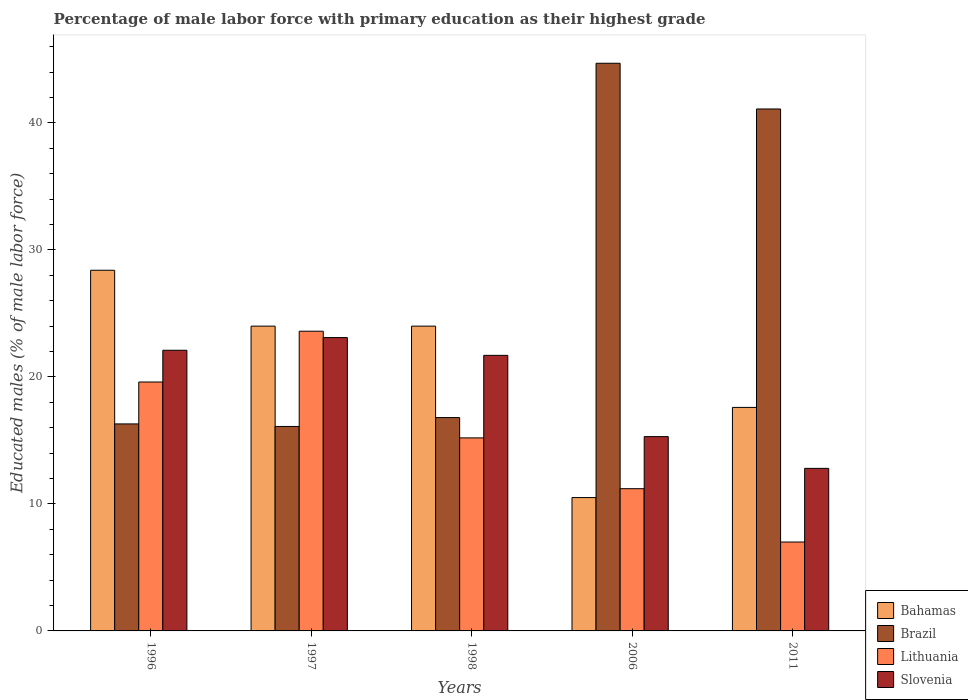How many groups of bars are there?
Make the answer very short. 5. Are the number of bars on each tick of the X-axis equal?
Offer a very short reply. Yes. How many bars are there on the 5th tick from the left?
Provide a succinct answer. 4. Across all years, what is the maximum percentage of male labor force with primary education in Slovenia?
Make the answer very short. 23.1. In which year was the percentage of male labor force with primary education in Slovenia minimum?
Your answer should be very brief. 2011. What is the total percentage of male labor force with primary education in Slovenia in the graph?
Your answer should be compact. 95. What is the difference between the percentage of male labor force with primary education in Bahamas in 1996 and that in 1997?
Your answer should be compact. 4.4. What is the difference between the percentage of male labor force with primary education in Brazil in 2011 and the percentage of male labor force with primary education in Bahamas in 1996?
Offer a terse response. 12.7. What is the average percentage of male labor force with primary education in Lithuania per year?
Provide a short and direct response. 15.32. In the year 2011, what is the difference between the percentage of male labor force with primary education in Bahamas and percentage of male labor force with primary education in Slovenia?
Make the answer very short. 4.8. What is the ratio of the percentage of male labor force with primary education in Brazil in 1996 to that in 1998?
Ensure brevity in your answer.  0.97. Is the difference between the percentage of male labor force with primary education in Bahamas in 1996 and 1998 greater than the difference between the percentage of male labor force with primary education in Slovenia in 1996 and 1998?
Keep it short and to the point. Yes. What is the difference between the highest and the second highest percentage of male labor force with primary education in Brazil?
Offer a terse response. 3.6. What is the difference between the highest and the lowest percentage of male labor force with primary education in Slovenia?
Keep it short and to the point. 10.3. Is the sum of the percentage of male labor force with primary education in Slovenia in 1998 and 2011 greater than the maximum percentage of male labor force with primary education in Lithuania across all years?
Keep it short and to the point. Yes. What does the 1st bar from the left in 1997 represents?
Provide a short and direct response. Bahamas. What does the 1st bar from the right in 1997 represents?
Provide a short and direct response. Slovenia. Is it the case that in every year, the sum of the percentage of male labor force with primary education in Bahamas and percentage of male labor force with primary education in Brazil is greater than the percentage of male labor force with primary education in Slovenia?
Your answer should be compact. Yes. What is the difference between two consecutive major ticks on the Y-axis?
Keep it short and to the point. 10. Are the values on the major ticks of Y-axis written in scientific E-notation?
Provide a short and direct response. No. Where does the legend appear in the graph?
Give a very brief answer. Bottom right. How are the legend labels stacked?
Provide a short and direct response. Vertical. What is the title of the graph?
Provide a short and direct response. Percentage of male labor force with primary education as their highest grade. What is the label or title of the Y-axis?
Offer a very short reply. Educated males (% of male labor force). What is the Educated males (% of male labor force) of Bahamas in 1996?
Ensure brevity in your answer.  28.4. What is the Educated males (% of male labor force) of Brazil in 1996?
Make the answer very short. 16.3. What is the Educated males (% of male labor force) in Lithuania in 1996?
Your answer should be very brief. 19.6. What is the Educated males (% of male labor force) of Slovenia in 1996?
Keep it short and to the point. 22.1. What is the Educated males (% of male labor force) in Brazil in 1997?
Offer a very short reply. 16.1. What is the Educated males (% of male labor force) in Lithuania in 1997?
Give a very brief answer. 23.6. What is the Educated males (% of male labor force) of Slovenia in 1997?
Offer a terse response. 23.1. What is the Educated males (% of male labor force) in Brazil in 1998?
Offer a very short reply. 16.8. What is the Educated males (% of male labor force) of Lithuania in 1998?
Ensure brevity in your answer.  15.2. What is the Educated males (% of male labor force) of Slovenia in 1998?
Keep it short and to the point. 21.7. What is the Educated males (% of male labor force) in Brazil in 2006?
Provide a short and direct response. 44.7. What is the Educated males (% of male labor force) of Lithuania in 2006?
Your answer should be compact. 11.2. What is the Educated males (% of male labor force) of Slovenia in 2006?
Your response must be concise. 15.3. What is the Educated males (% of male labor force) of Bahamas in 2011?
Your response must be concise. 17.6. What is the Educated males (% of male labor force) of Brazil in 2011?
Provide a succinct answer. 41.1. What is the Educated males (% of male labor force) of Lithuania in 2011?
Provide a short and direct response. 7. What is the Educated males (% of male labor force) of Slovenia in 2011?
Ensure brevity in your answer.  12.8. Across all years, what is the maximum Educated males (% of male labor force) in Bahamas?
Your answer should be compact. 28.4. Across all years, what is the maximum Educated males (% of male labor force) in Brazil?
Offer a terse response. 44.7. Across all years, what is the maximum Educated males (% of male labor force) of Lithuania?
Make the answer very short. 23.6. Across all years, what is the maximum Educated males (% of male labor force) in Slovenia?
Give a very brief answer. 23.1. Across all years, what is the minimum Educated males (% of male labor force) of Bahamas?
Offer a terse response. 10.5. Across all years, what is the minimum Educated males (% of male labor force) in Brazil?
Your answer should be very brief. 16.1. Across all years, what is the minimum Educated males (% of male labor force) in Lithuania?
Your answer should be very brief. 7. Across all years, what is the minimum Educated males (% of male labor force) of Slovenia?
Make the answer very short. 12.8. What is the total Educated males (% of male labor force) in Bahamas in the graph?
Give a very brief answer. 104.5. What is the total Educated males (% of male labor force) of Brazil in the graph?
Your answer should be very brief. 135. What is the total Educated males (% of male labor force) in Lithuania in the graph?
Give a very brief answer. 76.6. What is the difference between the Educated males (% of male labor force) in Brazil in 1996 and that in 1997?
Offer a terse response. 0.2. What is the difference between the Educated males (% of male labor force) in Lithuania in 1996 and that in 1997?
Your answer should be compact. -4. What is the difference between the Educated males (% of male labor force) of Brazil in 1996 and that in 1998?
Your answer should be compact. -0.5. What is the difference between the Educated males (% of male labor force) in Lithuania in 1996 and that in 1998?
Your answer should be compact. 4.4. What is the difference between the Educated males (% of male labor force) in Brazil in 1996 and that in 2006?
Your response must be concise. -28.4. What is the difference between the Educated males (% of male labor force) of Lithuania in 1996 and that in 2006?
Make the answer very short. 8.4. What is the difference between the Educated males (% of male labor force) of Brazil in 1996 and that in 2011?
Your response must be concise. -24.8. What is the difference between the Educated males (% of male labor force) in Lithuania in 1996 and that in 2011?
Give a very brief answer. 12.6. What is the difference between the Educated males (% of male labor force) in Slovenia in 1996 and that in 2011?
Keep it short and to the point. 9.3. What is the difference between the Educated males (% of male labor force) of Lithuania in 1997 and that in 1998?
Provide a succinct answer. 8.4. What is the difference between the Educated males (% of male labor force) in Slovenia in 1997 and that in 1998?
Offer a very short reply. 1.4. What is the difference between the Educated males (% of male labor force) in Brazil in 1997 and that in 2006?
Offer a very short reply. -28.6. What is the difference between the Educated males (% of male labor force) of Lithuania in 1997 and that in 2006?
Ensure brevity in your answer.  12.4. What is the difference between the Educated males (% of male labor force) of Slovenia in 1997 and that in 2011?
Ensure brevity in your answer.  10.3. What is the difference between the Educated males (% of male labor force) of Bahamas in 1998 and that in 2006?
Your response must be concise. 13.5. What is the difference between the Educated males (% of male labor force) in Brazil in 1998 and that in 2006?
Keep it short and to the point. -27.9. What is the difference between the Educated males (% of male labor force) in Slovenia in 1998 and that in 2006?
Your response must be concise. 6.4. What is the difference between the Educated males (% of male labor force) of Brazil in 1998 and that in 2011?
Offer a terse response. -24.3. What is the difference between the Educated males (% of male labor force) of Bahamas in 2006 and that in 2011?
Your answer should be compact. -7.1. What is the difference between the Educated males (% of male labor force) of Slovenia in 2006 and that in 2011?
Provide a succinct answer. 2.5. What is the difference between the Educated males (% of male labor force) in Bahamas in 1996 and the Educated males (% of male labor force) in Brazil in 1997?
Provide a short and direct response. 12.3. What is the difference between the Educated males (% of male labor force) in Bahamas in 1996 and the Educated males (% of male labor force) in Lithuania in 1997?
Offer a very short reply. 4.8. What is the difference between the Educated males (% of male labor force) in Bahamas in 1996 and the Educated males (% of male labor force) in Slovenia in 1997?
Keep it short and to the point. 5.3. What is the difference between the Educated males (% of male labor force) in Lithuania in 1996 and the Educated males (% of male labor force) in Slovenia in 1998?
Keep it short and to the point. -2.1. What is the difference between the Educated males (% of male labor force) of Bahamas in 1996 and the Educated males (% of male labor force) of Brazil in 2006?
Make the answer very short. -16.3. What is the difference between the Educated males (% of male labor force) of Bahamas in 1996 and the Educated males (% of male labor force) of Lithuania in 2006?
Your response must be concise. 17.2. What is the difference between the Educated males (% of male labor force) of Bahamas in 1996 and the Educated males (% of male labor force) of Slovenia in 2006?
Ensure brevity in your answer.  13.1. What is the difference between the Educated males (% of male labor force) in Brazil in 1996 and the Educated males (% of male labor force) in Slovenia in 2006?
Provide a short and direct response. 1. What is the difference between the Educated males (% of male labor force) of Bahamas in 1996 and the Educated males (% of male labor force) of Brazil in 2011?
Keep it short and to the point. -12.7. What is the difference between the Educated males (% of male labor force) of Bahamas in 1996 and the Educated males (% of male labor force) of Lithuania in 2011?
Provide a short and direct response. 21.4. What is the difference between the Educated males (% of male labor force) in Bahamas in 1996 and the Educated males (% of male labor force) in Slovenia in 2011?
Make the answer very short. 15.6. What is the difference between the Educated males (% of male labor force) in Brazil in 1996 and the Educated males (% of male labor force) in Lithuania in 2011?
Give a very brief answer. 9.3. What is the difference between the Educated males (% of male labor force) in Brazil in 1996 and the Educated males (% of male labor force) in Slovenia in 2011?
Make the answer very short. 3.5. What is the difference between the Educated males (% of male labor force) in Lithuania in 1996 and the Educated males (% of male labor force) in Slovenia in 2011?
Offer a terse response. 6.8. What is the difference between the Educated males (% of male labor force) of Bahamas in 1997 and the Educated males (% of male labor force) of Brazil in 1998?
Make the answer very short. 7.2. What is the difference between the Educated males (% of male labor force) of Bahamas in 1997 and the Educated males (% of male labor force) of Lithuania in 1998?
Keep it short and to the point. 8.8. What is the difference between the Educated males (% of male labor force) in Brazil in 1997 and the Educated males (% of male labor force) in Lithuania in 1998?
Your answer should be very brief. 0.9. What is the difference between the Educated males (% of male labor force) of Bahamas in 1997 and the Educated males (% of male labor force) of Brazil in 2006?
Your answer should be very brief. -20.7. What is the difference between the Educated males (% of male labor force) of Bahamas in 1997 and the Educated males (% of male labor force) of Lithuania in 2006?
Provide a short and direct response. 12.8. What is the difference between the Educated males (% of male labor force) of Bahamas in 1997 and the Educated males (% of male labor force) of Slovenia in 2006?
Keep it short and to the point. 8.7. What is the difference between the Educated males (% of male labor force) of Lithuania in 1997 and the Educated males (% of male labor force) of Slovenia in 2006?
Keep it short and to the point. 8.3. What is the difference between the Educated males (% of male labor force) in Bahamas in 1997 and the Educated males (% of male labor force) in Brazil in 2011?
Offer a terse response. -17.1. What is the difference between the Educated males (% of male labor force) of Brazil in 1997 and the Educated males (% of male labor force) of Lithuania in 2011?
Ensure brevity in your answer.  9.1. What is the difference between the Educated males (% of male labor force) in Brazil in 1997 and the Educated males (% of male labor force) in Slovenia in 2011?
Keep it short and to the point. 3.3. What is the difference between the Educated males (% of male labor force) in Lithuania in 1997 and the Educated males (% of male labor force) in Slovenia in 2011?
Your answer should be very brief. 10.8. What is the difference between the Educated males (% of male labor force) in Bahamas in 1998 and the Educated males (% of male labor force) in Brazil in 2006?
Keep it short and to the point. -20.7. What is the difference between the Educated males (% of male labor force) in Bahamas in 1998 and the Educated males (% of male labor force) in Slovenia in 2006?
Offer a very short reply. 8.7. What is the difference between the Educated males (% of male labor force) in Lithuania in 1998 and the Educated males (% of male labor force) in Slovenia in 2006?
Provide a short and direct response. -0.1. What is the difference between the Educated males (% of male labor force) in Bahamas in 1998 and the Educated males (% of male labor force) in Brazil in 2011?
Your answer should be very brief. -17.1. What is the difference between the Educated males (% of male labor force) in Bahamas in 1998 and the Educated males (% of male labor force) in Lithuania in 2011?
Make the answer very short. 17. What is the difference between the Educated males (% of male labor force) in Brazil in 1998 and the Educated males (% of male labor force) in Lithuania in 2011?
Ensure brevity in your answer.  9.8. What is the difference between the Educated males (% of male labor force) in Brazil in 1998 and the Educated males (% of male labor force) in Slovenia in 2011?
Ensure brevity in your answer.  4. What is the difference between the Educated males (% of male labor force) in Bahamas in 2006 and the Educated males (% of male labor force) in Brazil in 2011?
Give a very brief answer. -30.6. What is the difference between the Educated males (% of male labor force) of Bahamas in 2006 and the Educated males (% of male labor force) of Lithuania in 2011?
Offer a very short reply. 3.5. What is the difference between the Educated males (% of male labor force) of Bahamas in 2006 and the Educated males (% of male labor force) of Slovenia in 2011?
Give a very brief answer. -2.3. What is the difference between the Educated males (% of male labor force) in Brazil in 2006 and the Educated males (% of male labor force) in Lithuania in 2011?
Offer a very short reply. 37.7. What is the difference between the Educated males (% of male labor force) of Brazil in 2006 and the Educated males (% of male labor force) of Slovenia in 2011?
Provide a succinct answer. 31.9. What is the average Educated males (% of male labor force) of Bahamas per year?
Your answer should be very brief. 20.9. What is the average Educated males (% of male labor force) of Lithuania per year?
Your answer should be very brief. 15.32. What is the average Educated males (% of male labor force) in Slovenia per year?
Keep it short and to the point. 19. In the year 1996, what is the difference between the Educated males (% of male labor force) of Bahamas and Educated males (% of male labor force) of Brazil?
Keep it short and to the point. 12.1. In the year 1996, what is the difference between the Educated males (% of male labor force) in Brazil and Educated males (% of male labor force) in Slovenia?
Your answer should be very brief. -5.8. In the year 1996, what is the difference between the Educated males (% of male labor force) of Lithuania and Educated males (% of male labor force) of Slovenia?
Your response must be concise. -2.5. In the year 1997, what is the difference between the Educated males (% of male labor force) of Brazil and Educated males (% of male labor force) of Slovenia?
Make the answer very short. -7. In the year 1998, what is the difference between the Educated males (% of male labor force) of Bahamas and Educated males (% of male labor force) of Lithuania?
Provide a short and direct response. 8.8. In the year 1998, what is the difference between the Educated males (% of male labor force) in Bahamas and Educated males (% of male labor force) in Slovenia?
Provide a succinct answer. 2.3. In the year 1998, what is the difference between the Educated males (% of male labor force) in Brazil and Educated males (% of male labor force) in Lithuania?
Give a very brief answer. 1.6. In the year 2006, what is the difference between the Educated males (% of male labor force) in Bahamas and Educated males (% of male labor force) in Brazil?
Ensure brevity in your answer.  -34.2. In the year 2006, what is the difference between the Educated males (% of male labor force) in Bahamas and Educated males (% of male labor force) in Lithuania?
Provide a succinct answer. -0.7. In the year 2006, what is the difference between the Educated males (% of male labor force) of Bahamas and Educated males (% of male labor force) of Slovenia?
Provide a succinct answer. -4.8. In the year 2006, what is the difference between the Educated males (% of male labor force) of Brazil and Educated males (% of male labor force) of Lithuania?
Give a very brief answer. 33.5. In the year 2006, what is the difference between the Educated males (% of male labor force) of Brazil and Educated males (% of male labor force) of Slovenia?
Offer a terse response. 29.4. In the year 2011, what is the difference between the Educated males (% of male labor force) in Bahamas and Educated males (% of male labor force) in Brazil?
Offer a very short reply. -23.5. In the year 2011, what is the difference between the Educated males (% of male labor force) in Bahamas and Educated males (% of male labor force) in Slovenia?
Provide a succinct answer. 4.8. In the year 2011, what is the difference between the Educated males (% of male labor force) of Brazil and Educated males (% of male labor force) of Lithuania?
Make the answer very short. 34.1. In the year 2011, what is the difference between the Educated males (% of male labor force) in Brazil and Educated males (% of male labor force) in Slovenia?
Give a very brief answer. 28.3. In the year 2011, what is the difference between the Educated males (% of male labor force) of Lithuania and Educated males (% of male labor force) of Slovenia?
Ensure brevity in your answer.  -5.8. What is the ratio of the Educated males (% of male labor force) of Bahamas in 1996 to that in 1997?
Offer a very short reply. 1.18. What is the ratio of the Educated males (% of male labor force) of Brazil in 1996 to that in 1997?
Provide a short and direct response. 1.01. What is the ratio of the Educated males (% of male labor force) in Lithuania in 1996 to that in 1997?
Your response must be concise. 0.83. What is the ratio of the Educated males (% of male labor force) in Slovenia in 1996 to that in 1997?
Provide a succinct answer. 0.96. What is the ratio of the Educated males (% of male labor force) in Bahamas in 1996 to that in 1998?
Provide a succinct answer. 1.18. What is the ratio of the Educated males (% of male labor force) in Brazil in 1996 to that in 1998?
Give a very brief answer. 0.97. What is the ratio of the Educated males (% of male labor force) of Lithuania in 1996 to that in 1998?
Keep it short and to the point. 1.29. What is the ratio of the Educated males (% of male labor force) in Slovenia in 1996 to that in 1998?
Your answer should be compact. 1.02. What is the ratio of the Educated males (% of male labor force) in Bahamas in 1996 to that in 2006?
Your answer should be very brief. 2.7. What is the ratio of the Educated males (% of male labor force) of Brazil in 1996 to that in 2006?
Provide a short and direct response. 0.36. What is the ratio of the Educated males (% of male labor force) in Slovenia in 1996 to that in 2006?
Keep it short and to the point. 1.44. What is the ratio of the Educated males (% of male labor force) in Bahamas in 1996 to that in 2011?
Your response must be concise. 1.61. What is the ratio of the Educated males (% of male labor force) of Brazil in 1996 to that in 2011?
Offer a very short reply. 0.4. What is the ratio of the Educated males (% of male labor force) in Lithuania in 1996 to that in 2011?
Make the answer very short. 2.8. What is the ratio of the Educated males (% of male labor force) of Slovenia in 1996 to that in 2011?
Provide a succinct answer. 1.73. What is the ratio of the Educated males (% of male labor force) in Bahamas in 1997 to that in 1998?
Provide a short and direct response. 1. What is the ratio of the Educated males (% of male labor force) in Lithuania in 1997 to that in 1998?
Offer a terse response. 1.55. What is the ratio of the Educated males (% of male labor force) of Slovenia in 1997 to that in 1998?
Your answer should be compact. 1.06. What is the ratio of the Educated males (% of male labor force) in Bahamas in 1997 to that in 2006?
Give a very brief answer. 2.29. What is the ratio of the Educated males (% of male labor force) in Brazil in 1997 to that in 2006?
Offer a very short reply. 0.36. What is the ratio of the Educated males (% of male labor force) of Lithuania in 1997 to that in 2006?
Your answer should be compact. 2.11. What is the ratio of the Educated males (% of male labor force) of Slovenia in 1997 to that in 2006?
Keep it short and to the point. 1.51. What is the ratio of the Educated males (% of male labor force) of Bahamas in 1997 to that in 2011?
Make the answer very short. 1.36. What is the ratio of the Educated males (% of male labor force) in Brazil in 1997 to that in 2011?
Offer a terse response. 0.39. What is the ratio of the Educated males (% of male labor force) in Lithuania in 1997 to that in 2011?
Provide a short and direct response. 3.37. What is the ratio of the Educated males (% of male labor force) of Slovenia in 1997 to that in 2011?
Give a very brief answer. 1.8. What is the ratio of the Educated males (% of male labor force) in Bahamas in 1998 to that in 2006?
Make the answer very short. 2.29. What is the ratio of the Educated males (% of male labor force) in Brazil in 1998 to that in 2006?
Provide a succinct answer. 0.38. What is the ratio of the Educated males (% of male labor force) of Lithuania in 1998 to that in 2006?
Your answer should be very brief. 1.36. What is the ratio of the Educated males (% of male labor force) in Slovenia in 1998 to that in 2006?
Keep it short and to the point. 1.42. What is the ratio of the Educated males (% of male labor force) in Bahamas in 1998 to that in 2011?
Your response must be concise. 1.36. What is the ratio of the Educated males (% of male labor force) in Brazil in 1998 to that in 2011?
Ensure brevity in your answer.  0.41. What is the ratio of the Educated males (% of male labor force) in Lithuania in 1998 to that in 2011?
Give a very brief answer. 2.17. What is the ratio of the Educated males (% of male labor force) in Slovenia in 1998 to that in 2011?
Offer a very short reply. 1.7. What is the ratio of the Educated males (% of male labor force) of Bahamas in 2006 to that in 2011?
Offer a terse response. 0.6. What is the ratio of the Educated males (% of male labor force) in Brazil in 2006 to that in 2011?
Keep it short and to the point. 1.09. What is the ratio of the Educated males (% of male labor force) in Slovenia in 2006 to that in 2011?
Offer a terse response. 1.2. What is the difference between the highest and the second highest Educated males (% of male labor force) in Lithuania?
Your answer should be very brief. 4. What is the difference between the highest and the second highest Educated males (% of male labor force) in Slovenia?
Offer a terse response. 1. What is the difference between the highest and the lowest Educated males (% of male labor force) of Bahamas?
Your response must be concise. 17.9. What is the difference between the highest and the lowest Educated males (% of male labor force) of Brazil?
Give a very brief answer. 28.6. What is the difference between the highest and the lowest Educated males (% of male labor force) of Lithuania?
Provide a succinct answer. 16.6. What is the difference between the highest and the lowest Educated males (% of male labor force) of Slovenia?
Give a very brief answer. 10.3. 